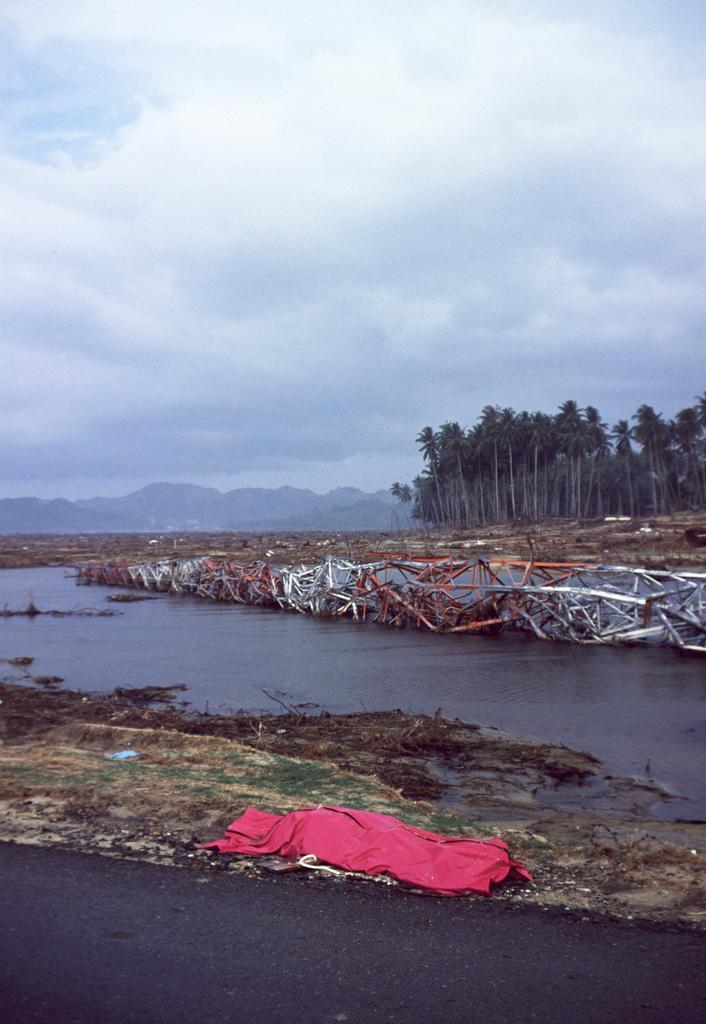Could you give a brief overview of what you see in this image? In this image there is the sky truncated towards the top of the image, there are clouds in the sky, there are mountains truncated towards the left of the image, there are trees truncated towards the right of the image, there is water truncated towards the bottom of the image, there is water truncated towards the left of the image, there is a cloth on the ground, there is a tower truncated towards the right of the image. 